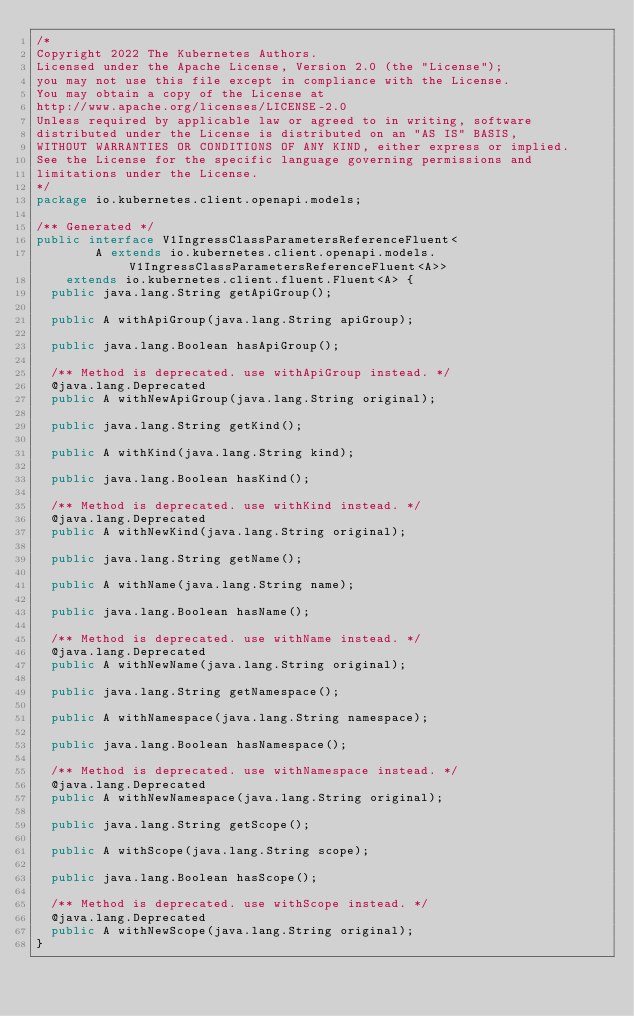Convert code to text. <code><loc_0><loc_0><loc_500><loc_500><_Java_>/*
Copyright 2022 The Kubernetes Authors.
Licensed under the Apache License, Version 2.0 (the "License");
you may not use this file except in compliance with the License.
You may obtain a copy of the License at
http://www.apache.org/licenses/LICENSE-2.0
Unless required by applicable law or agreed to in writing, software
distributed under the License is distributed on an "AS IS" BASIS,
WITHOUT WARRANTIES OR CONDITIONS OF ANY KIND, either express or implied.
See the License for the specific language governing permissions and
limitations under the License.
*/
package io.kubernetes.client.openapi.models;

/** Generated */
public interface V1IngressClassParametersReferenceFluent<
        A extends io.kubernetes.client.openapi.models.V1IngressClassParametersReferenceFluent<A>>
    extends io.kubernetes.client.fluent.Fluent<A> {
  public java.lang.String getApiGroup();

  public A withApiGroup(java.lang.String apiGroup);

  public java.lang.Boolean hasApiGroup();

  /** Method is deprecated. use withApiGroup instead. */
  @java.lang.Deprecated
  public A withNewApiGroup(java.lang.String original);

  public java.lang.String getKind();

  public A withKind(java.lang.String kind);

  public java.lang.Boolean hasKind();

  /** Method is deprecated. use withKind instead. */
  @java.lang.Deprecated
  public A withNewKind(java.lang.String original);

  public java.lang.String getName();

  public A withName(java.lang.String name);

  public java.lang.Boolean hasName();

  /** Method is deprecated. use withName instead. */
  @java.lang.Deprecated
  public A withNewName(java.lang.String original);

  public java.lang.String getNamespace();

  public A withNamespace(java.lang.String namespace);

  public java.lang.Boolean hasNamespace();

  /** Method is deprecated. use withNamespace instead. */
  @java.lang.Deprecated
  public A withNewNamespace(java.lang.String original);

  public java.lang.String getScope();

  public A withScope(java.lang.String scope);

  public java.lang.Boolean hasScope();

  /** Method is deprecated. use withScope instead. */
  @java.lang.Deprecated
  public A withNewScope(java.lang.String original);
}
</code> 